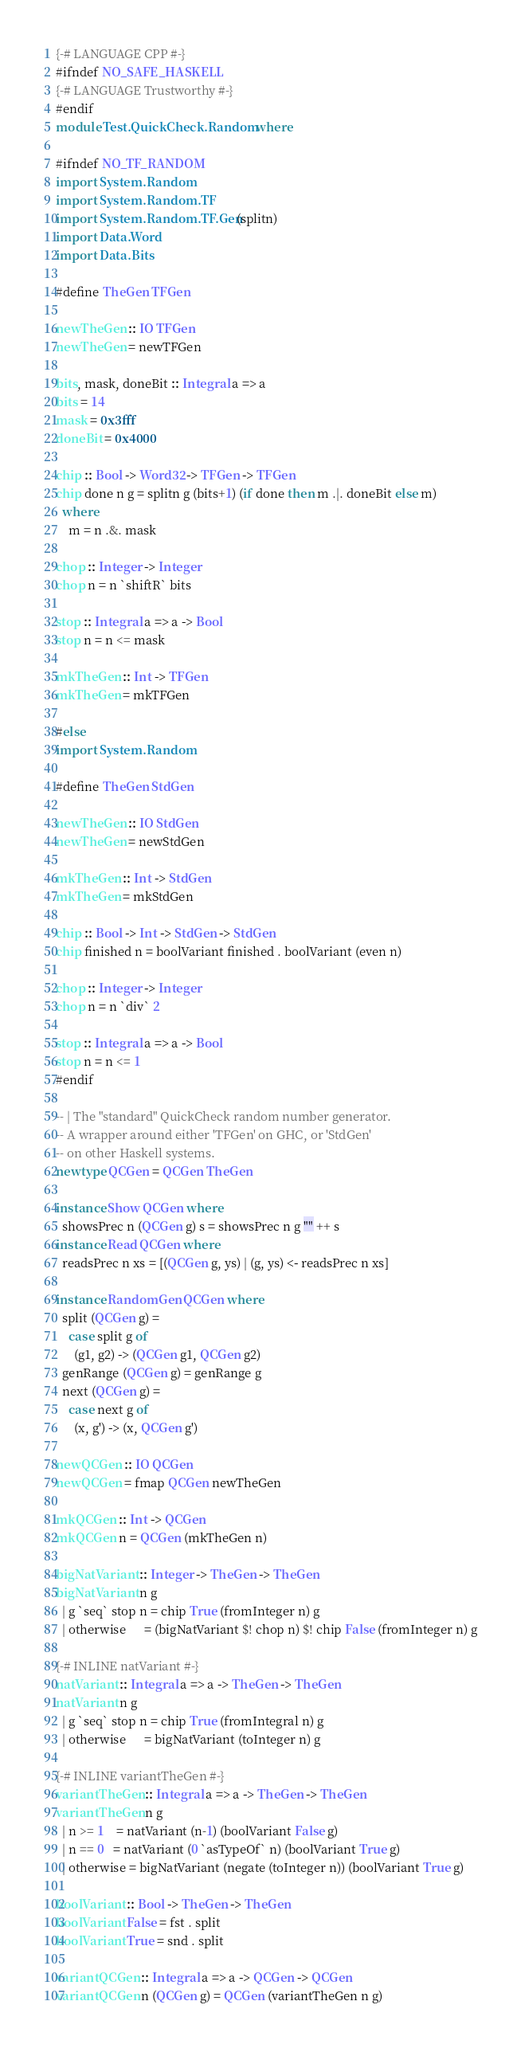<code> <loc_0><loc_0><loc_500><loc_500><_Haskell_>{-# LANGUAGE CPP #-}
#ifndef NO_SAFE_HASKELL
{-# LANGUAGE Trustworthy #-}
#endif
module Test.QuickCheck.Random where

#ifndef NO_TF_RANDOM
import System.Random
import System.Random.TF
import System.Random.TF.Gen(splitn)
import Data.Word
import Data.Bits

#define TheGen TFGen

newTheGen :: IO TFGen
newTheGen = newTFGen

bits, mask, doneBit :: Integral a => a
bits = 14
mask = 0x3fff
doneBit = 0x4000

chip :: Bool -> Word32 -> TFGen -> TFGen
chip done n g = splitn g (bits+1) (if done then m .|. doneBit else m)
  where
    m = n .&. mask

chop :: Integer -> Integer
chop n = n `shiftR` bits

stop :: Integral a => a -> Bool
stop n = n <= mask

mkTheGen :: Int -> TFGen
mkTheGen = mkTFGen

#else
import System.Random

#define TheGen StdGen

newTheGen :: IO StdGen
newTheGen = newStdGen

mkTheGen :: Int -> StdGen
mkTheGen = mkStdGen

chip :: Bool -> Int -> StdGen -> StdGen
chip finished n = boolVariant finished . boolVariant (even n)

chop :: Integer -> Integer
chop n = n `div` 2

stop :: Integral a => a -> Bool
stop n = n <= 1
#endif

-- | The "standard" QuickCheck random number generator.
-- A wrapper around either 'TFGen' on GHC, or 'StdGen'
-- on other Haskell systems.
newtype QCGen = QCGen TheGen

instance Show QCGen where
  showsPrec n (QCGen g) s = showsPrec n g "" ++ s
instance Read QCGen where
  readsPrec n xs = [(QCGen g, ys) | (g, ys) <- readsPrec n xs]

instance RandomGen QCGen where
  split (QCGen g) =
    case split g of
      (g1, g2) -> (QCGen g1, QCGen g2)
  genRange (QCGen g) = genRange g
  next (QCGen g) =
    case next g of
      (x, g') -> (x, QCGen g')

newQCGen :: IO QCGen
newQCGen = fmap QCGen newTheGen

mkQCGen :: Int -> QCGen
mkQCGen n = QCGen (mkTheGen n)

bigNatVariant :: Integer -> TheGen -> TheGen
bigNatVariant n g
  | g `seq` stop n = chip True (fromInteger n) g
  | otherwise      = (bigNatVariant $! chop n) $! chip False (fromInteger n) g

{-# INLINE natVariant #-}
natVariant :: Integral a => a -> TheGen -> TheGen
natVariant n g
  | g `seq` stop n = chip True (fromIntegral n) g
  | otherwise      = bigNatVariant (toInteger n) g

{-# INLINE variantTheGen #-}
variantTheGen :: Integral a => a -> TheGen -> TheGen
variantTheGen n g
  | n >= 1    = natVariant (n-1) (boolVariant False g)
  | n == 0   = natVariant (0 `asTypeOf` n) (boolVariant True g)
  | otherwise = bigNatVariant (negate (toInteger n)) (boolVariant True g)

boolVariant :: Bool -> TheGen -> TheGen
boolVariant False = fst . split
boolVariant True = snd . split

variantQCGen :: Integral a => a -> QCGen -> QCGen
variantQCGen n (QCGen g) = QCGen (variantTheGen n g)
</code> 